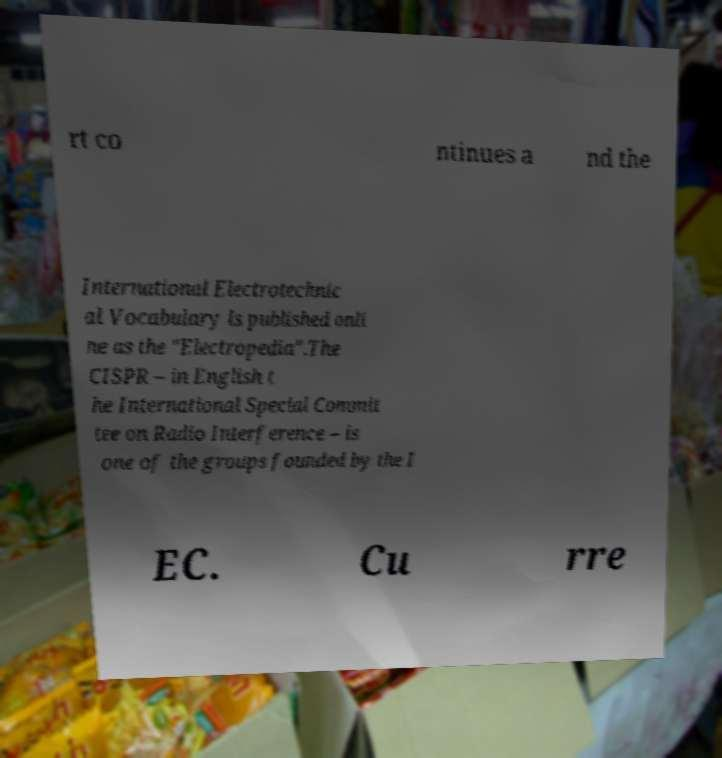I need the written content from this picture converted into text. Can you do that? rt co ntinues a nd the International Electrotechnic al Vocabulary is published onli ne as the "Electropedia".The CISPR – in English t he International Special Commit tee on Radio Interference – is one of the groups founded by the I EC. Cu rre 